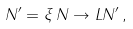<formula> <loc_0><loc_0><loc_500><loc_500>N ^ { \prime } = \xi \, N \rightarrow L N ^ { \prime } \, ,</formula> 